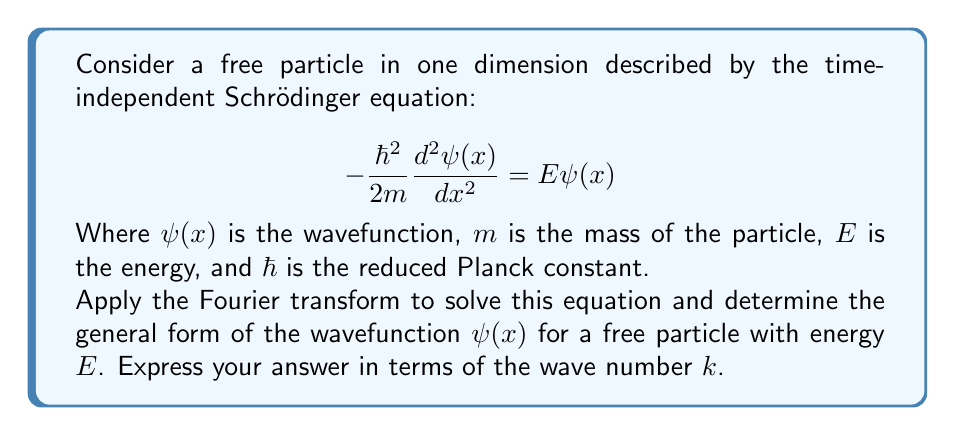Teach me how to tackle this problem. Let's approach this problem step-by-step:

1) First, we define the Fourier transform of $\psi(x)$ as:

   $$ \tilde{\psi}(k) = \frac{1}{\sqrt{2\pi}} \int_{-\infty}^{\infty} \psi(x) e^{-ikx} dx $$

2) We apply the Fourier transform to both sides of the Schrödinger equation:

   $$ -\frac{\hbar^2}{2m}\mathcal{F}\left[\frac{d^2\psi(x)}{dx^2}\right] = E\mathcal{F}[\psi(x)] $$

3) Using the property of Fourier transforms that $\mathcal{F}[\frac{d^2f}{dx^2}] = -k^2\tilde{f}(k)$, we get:

   $$ \frac{\hbar^2k^2}{2m}\tilde{\psi}(k) = E\tilde{\psi}(k) $$

4) This equation tells us that $\tilde{\psi}(k)$ is non-zero only when:

   $$ \frac{\hbar^2k^2}{2m} = E $$

5) Solving for $k$, we get:

   $$ k = \pm\sqrt{\frac{2mE}{\hbar^2}} $$

6) This means that $\tilde{\psi}(k)$ must be of the form:

   $$ \tilde{\psi}(k) = A\delta(k-k_0) + B\delta(k+k_0) $$

   where $k_0 = \sqrt{\frac{2mE}{\hbar^2}}$, and $A$ and $B$ are complex constants.

7) To get $\psi(x)$, we need to take the inverse Fourier transform:

   $$ \psi(x) = \frac{1}{\sqrt{2\pi}} \int_{-\infty}^{\infty} \tilde{\psi}(k) e^{ikx} dk $$

8) Substituting the form of $\tilde{\psi}(k)$ from step 6:

   $$ \psi(x) = \frac{1}{\sqrt{2\pi}} (Ae^{ik_0x} + Be^{-ik_0x}) $$

9) This can be written more compactly as:

   $$ \psi(x) = Ce^{ik_0x} + De^{-ik_0x} $$

   where $C$ and $D$ are new complex constants.
Answer: $\psi(x) = Ce^{ikx} + De^{-ikx}$, where $k = \sqrt{\frac{2mE}{\hbar^2}}$ 